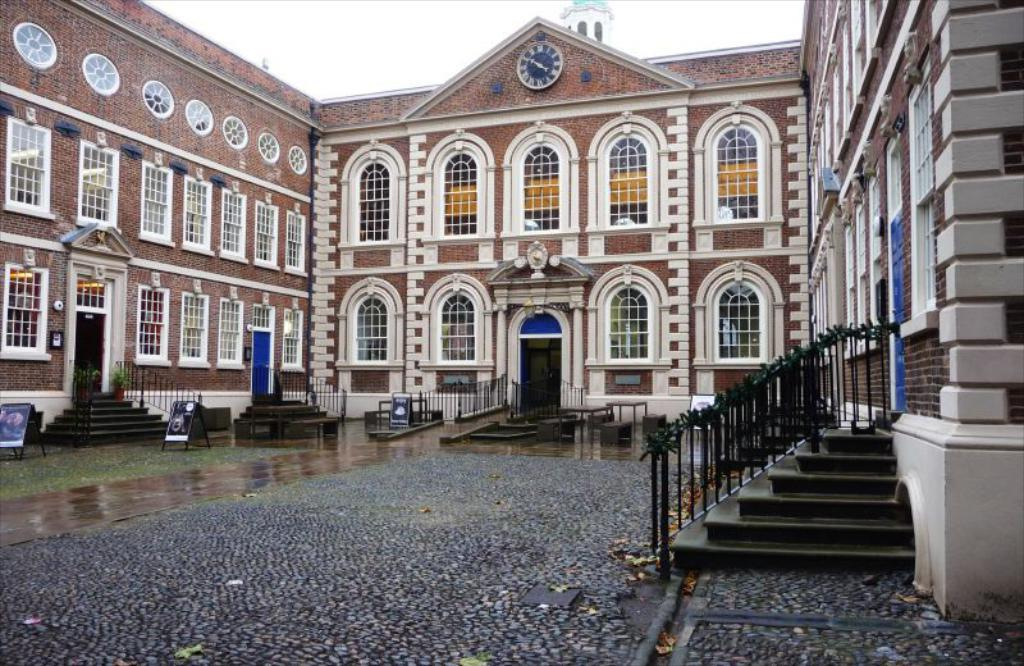What type of structure is present in the image? There is a building in the image. What feature can be observed on the building's exterior? The building has glass windows. Are there any architectural elements visible in the image? Yes, there are staircases in the image. What is present on the floor of the building? There are wooden stand boards on the floor. What can be seen on the wall of the building? There is a clock on the wall of the building. How does the visitor use the news in the image? There is no visitor or news present in the image; it only features a building with glass windows, staircases, wooden stand boards, and a clock on the wall. 